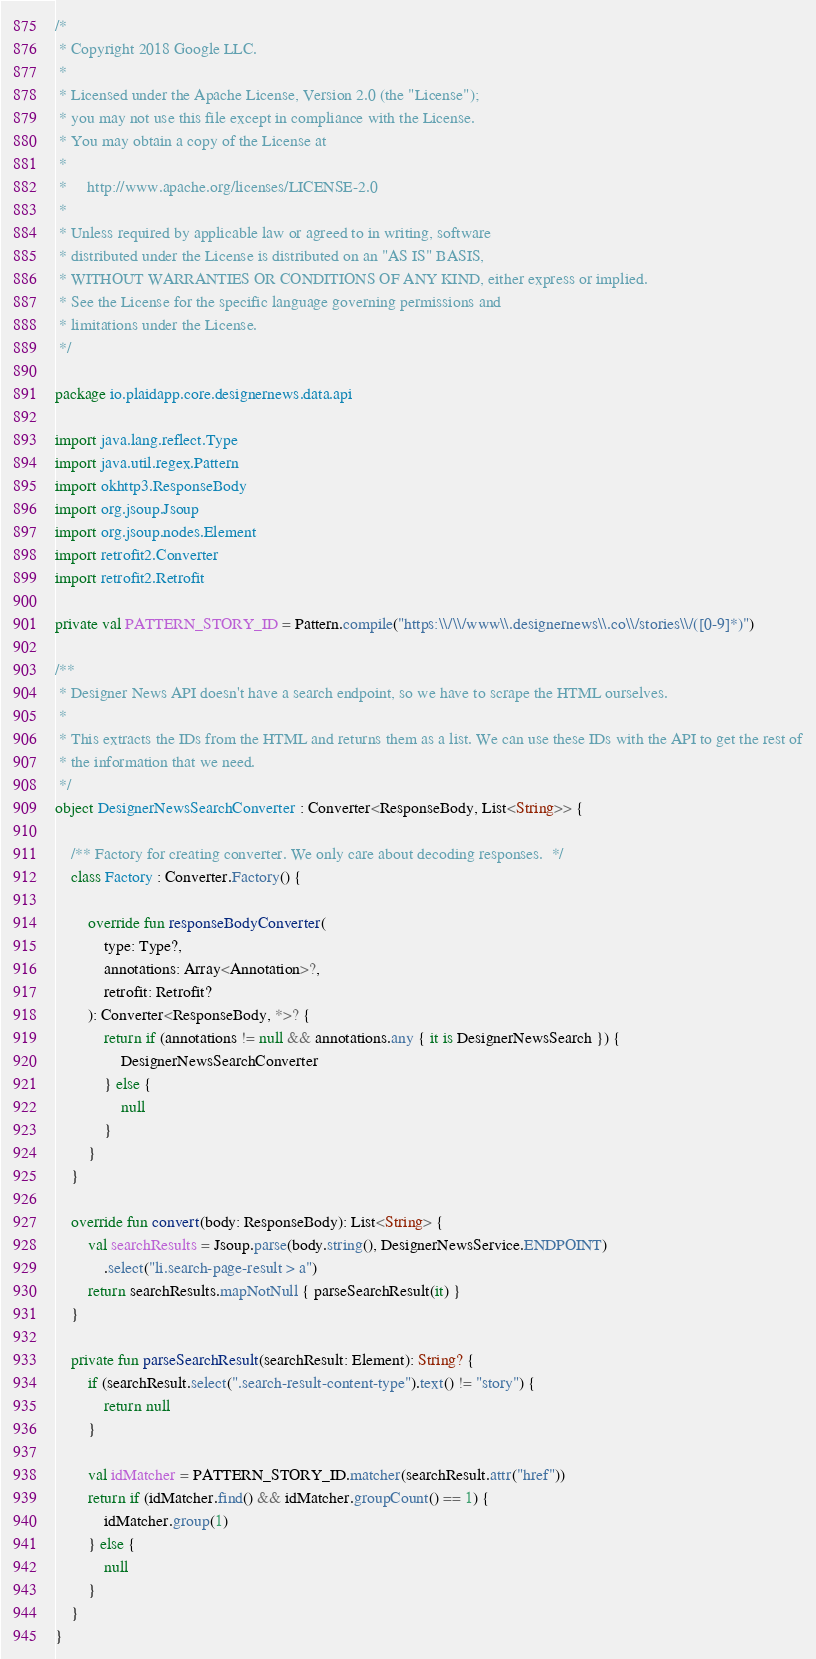Convert code to text. <code><loc_0><loc_0><loc_500><loc_500><_Kotlin_>/*
 * Copyright 2018 Google LLC.
 *
 * Licensed under the Apache License, Version 2.0 (the "License");
 * you may not use this file except in compliance with the License.
 * You may obtain a copy of the License at
 *
 *     http://www.apache.org/licenses/LICENSE-2.0
 *
 * Unless required by applicable law or agreed to in writing, software
 * distributed under the License is distributed on an "AS IS" BASIS,
 * WITHOUT WARRANTIES OR CONDITIONS OF ANY KIND, either express or implied.
 * See the License for the specific language governing permissions and
 * limitations under the License.
 */

package io.plaidapp.core.designernews.data.api

import java.lang.reflect.Type
import java.util.regex.Pattern
import okhttp3.ResponseBody
import org.jsoup.Jsoup
import org.jsoup.nodes.Element
import retrofit2.Converter
import retrofit2.Retrofit

private val PATTERN_STORY_ID = Pattern.compile("https:\\/\\/www\\.designernews\\.co\\/stories\\/([0-9]*)")

/**
 * Designer News API doesn't have a search endpoint, so we have to scrape the HTML ourselves.
 *
 * This extracts the IDs from the HTML and returns them as a list. We can use these IDs with the API to get the rest of
 * the information that we need.
 */
object DesignerNewsSearchConverter : Converter<ResponseBody, List<String>> {

    /** Factory for creating converter. We only care about decoding responses.  */
    class Factory : Converter.Factory() {

        override fun responseBodyConverter(
            type: Type?,
            annotations: Array<Annotation>?,
            retrofit: Retrofit?
        ): Converter<ResponseBody, *>? {
            return if (annotations != null && annotations.any { it is DesignerNewsSearch }) {
                DesignerNewsSearchConverter
            } else {
                null
            }
        }
    }

    override fun convert(body: ResponseBody): List<String> {
        val searchResults = Jsoup.parse(body.string(), DesignerNewsService.ENDPOINT)
            .select("li.search-page-result > a")
        return searchResults.mapNotNull { parseSearchResult(it) }
    }

    private fun parseSearchResult(searchResult: Element): String? {
        if (searchResult.select(".search-result-content-type").text() != "story") {
            return null
        }

        val idMatcher = PATTERN_STORY_ID.matcher(searchResult.attr("href"))
        return if (idMatcher.find() && idMatcher.groupCount() == 1) {
            idMatcher.group(1)
        } else {
            null
        }
    }
}
</code> 